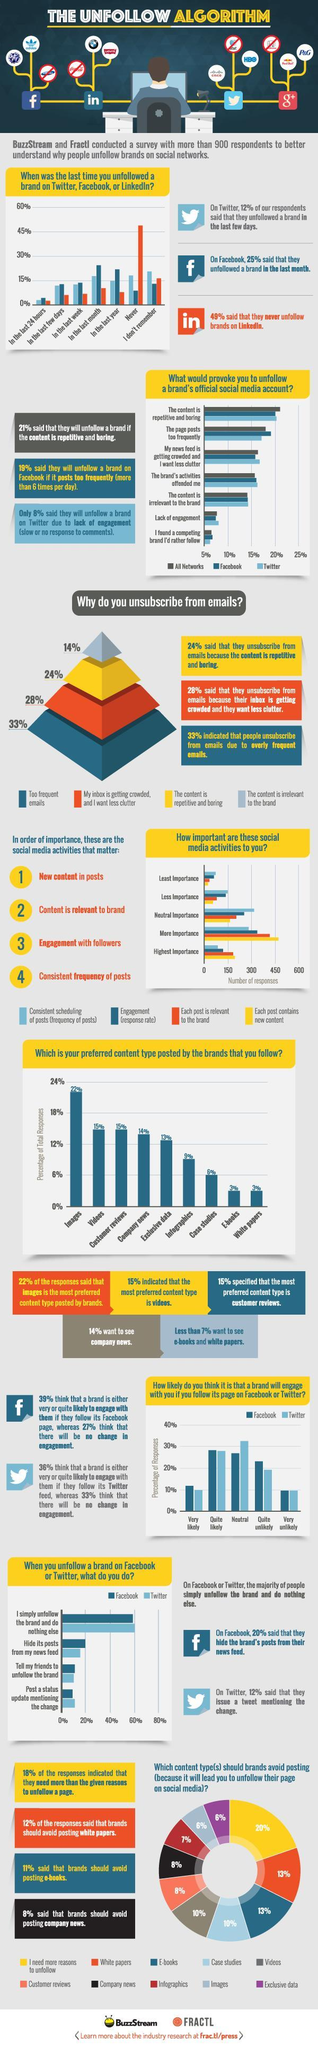What do 60% of Twitter users do after unfollowing a brand?
Answer the question with a short phrase. I simply unfollow the brand and do nothing else Which content type posted by brands is preferred by 9% of respondents? Infographics Which content type is the third most preferred ? Company News What percent of Facebook users have said that they will unfollow  a brand if content is repetitive and boring? 20% What is the top reason for unsubscribing from emails? Too frequent emails Which is the third most important social media activity listed? Engagement with followers Which social media activity crossed 450 responses as per the graph? Each post contains new content What reason for unsubscribing emails is at the top of the pyramid? The content is irrelevant to the brand What percentage of people need more reasons to unfollow? 20% Which colour represents "The content is repetitive and boring" in the pyramid - red, blue or yellow? yellow What is the reason 7% of people will unfollow a brand on social media according to the pie chart? Infographics What percent of Facebook users hide its post from newsfeed after unfollowing a brand? 20% 